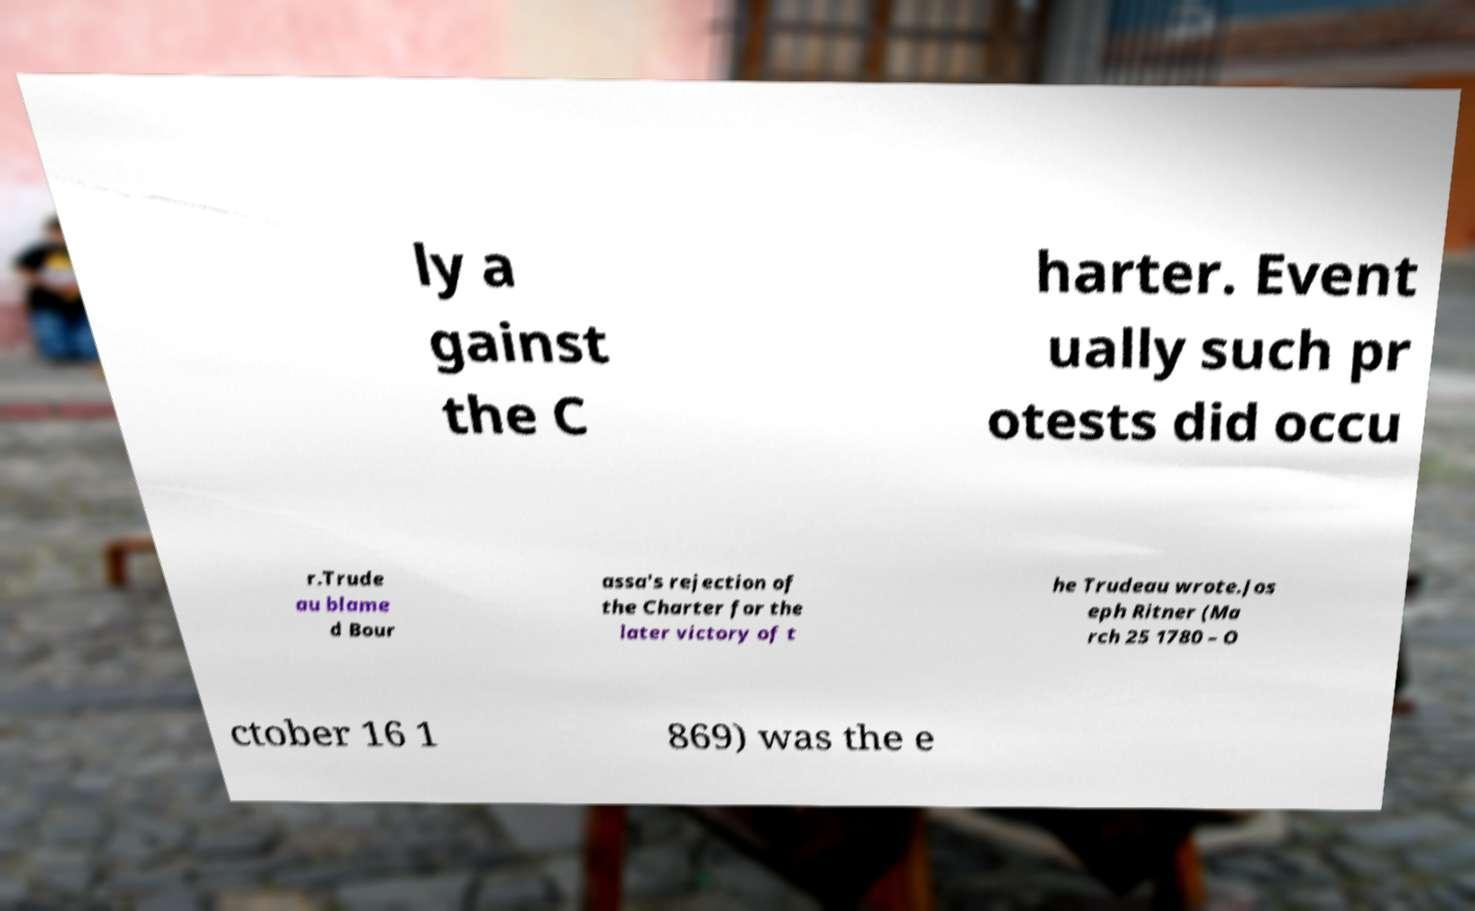Could you assist in decoding the text presented in this image and type it out clearly? ly a gainst the C harter. Event ually such pr otests did occu r.Trude au blame d Bour assa's rejection of the Charter for the later victory of t he Trudeau wrote.Jos eph Ritner (Ma rch 25 1780 – O ctober 16 1 869) was the e 